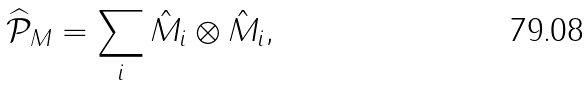Convert formula to latex. <formula><loc_0><loc_0><loc_500><loc_500>\widehat { \mathcal { P } } _ { M } = \sum _ { i } \hat { M } _ { i } \otimes \hat { M } _ { i } ,</formula> 